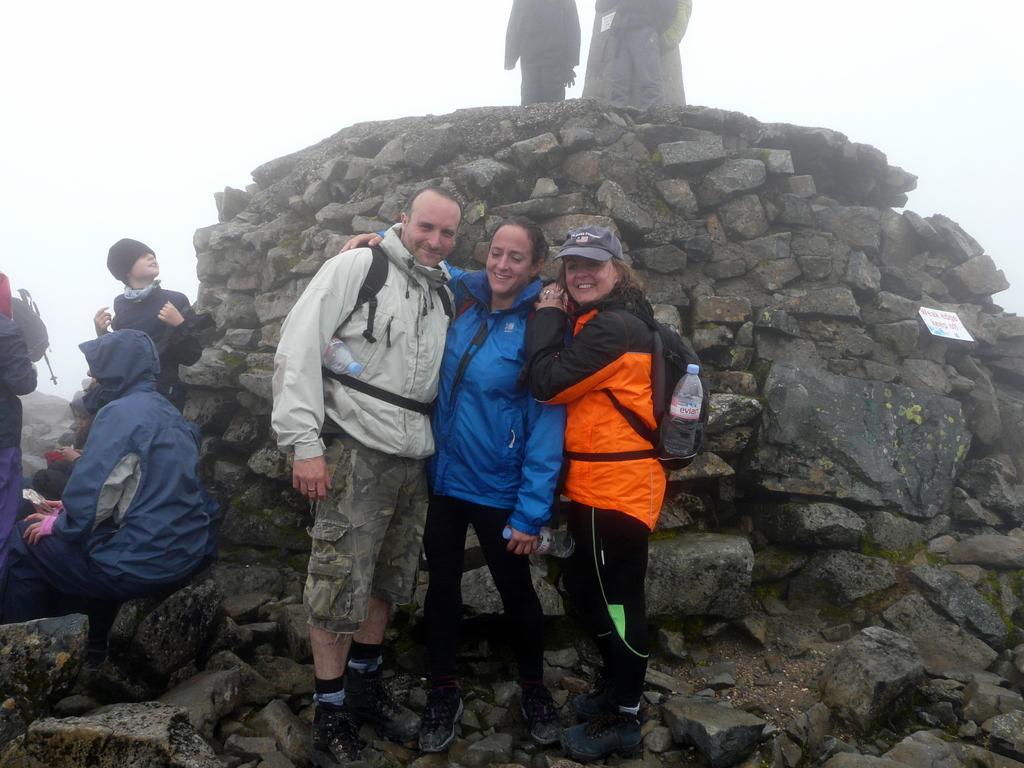Describe this image in one or two sentences. In this image there are three persons in the middle who are standing on the stones. There is a man on the left side who is wearing the white jacket and there is a woman on the right side who is wearing the jacket and a bag. On the left side there are few people sitting on the stones. In the background there are stones on which there are two persons. 